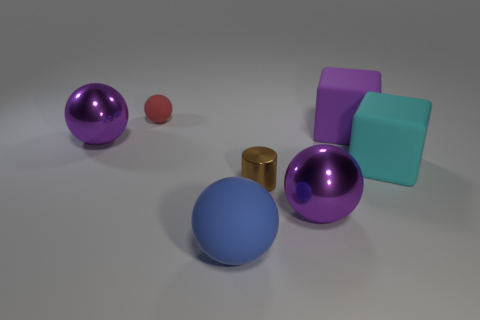Add 3 large purple balls. How many objects exist? 10 Subtract all balls. How many objects are left? 3 Add 7 brown metallic cylinders. How many brown metallic cylinders exist? 8 Subtract 0 gray cylinders. How many objects are left? 7 Subtract all large metal spheres. Subtract all purple balls. How many objects are left? 3 Add 7 tiny brown metallic things. How many tiny brown metallic things are left? 8 